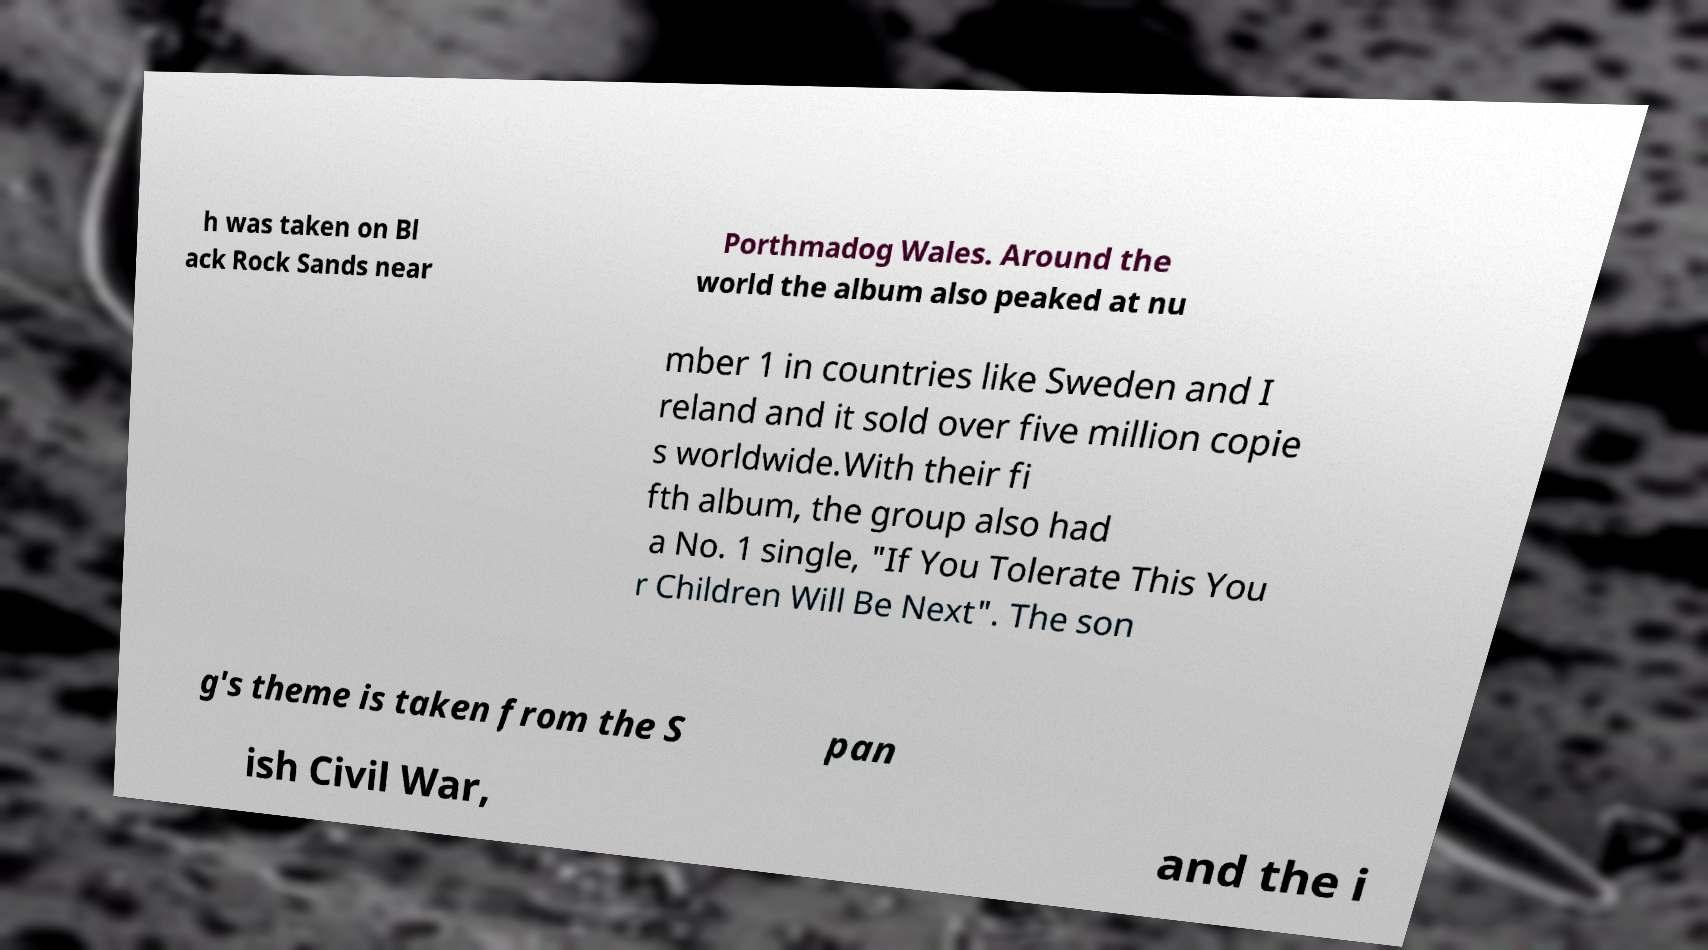Could you assist in decoding the text presented in this image and type it out clearly? h was taken on Bl ack Rock Sands near Porthmadog Wales. Around the world the album also peaked at nu mber 1 in countries like Sweden and I reland and it sold over five million copie s worldwide.With their fi fth album, the group also had a No. 1 single, "If You Tolerate This You r Children Will Be Next". The son g's theme is taken from the S pan ish Civil War, and the i 